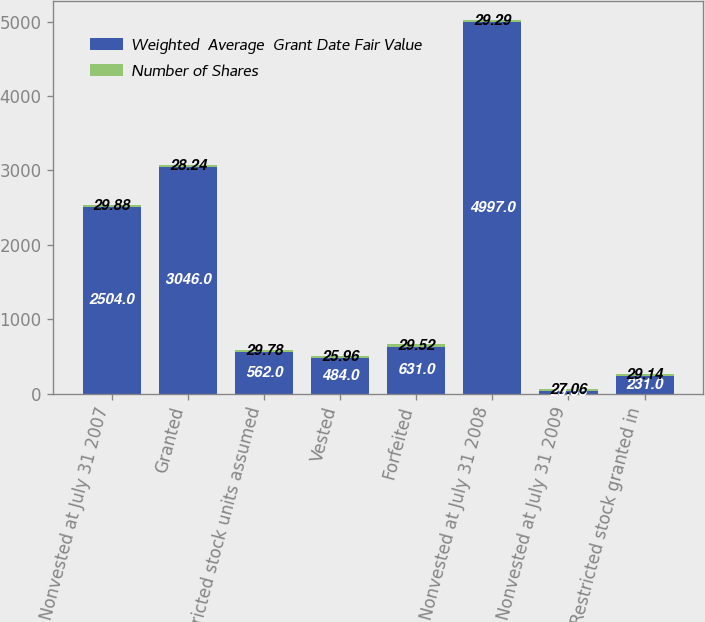Convert chart to OTSL. <chart><loc_0><loc_0><loc_500><loc_500><stacked_bar_chart><ecel><fcel>Nonvested at July 31 2007<fcel>Granted<fcel>Restricted stock units assumed<fcel>Vested<fcel>Forfeited<fcel>Nonvested at July 31 2008<fcel>Nonvested at July 31 2009<fcel>Restricted stock granted in<nl><fcel>Weighted  Average  Grant Date Fair Value<fcel>2504<fcel>3046<fcel>562<fcel>484<fcel>631<fcel>4997<fcel>29.88<fcel>231<nl><fcel>Number of Shares<fcel>29.88<fcel>28.24<fcel>29.78<fcel>25.96<fcel>29.52<fcel>29.29<fcel>27.06<fcel>29.14<nl></chart> 